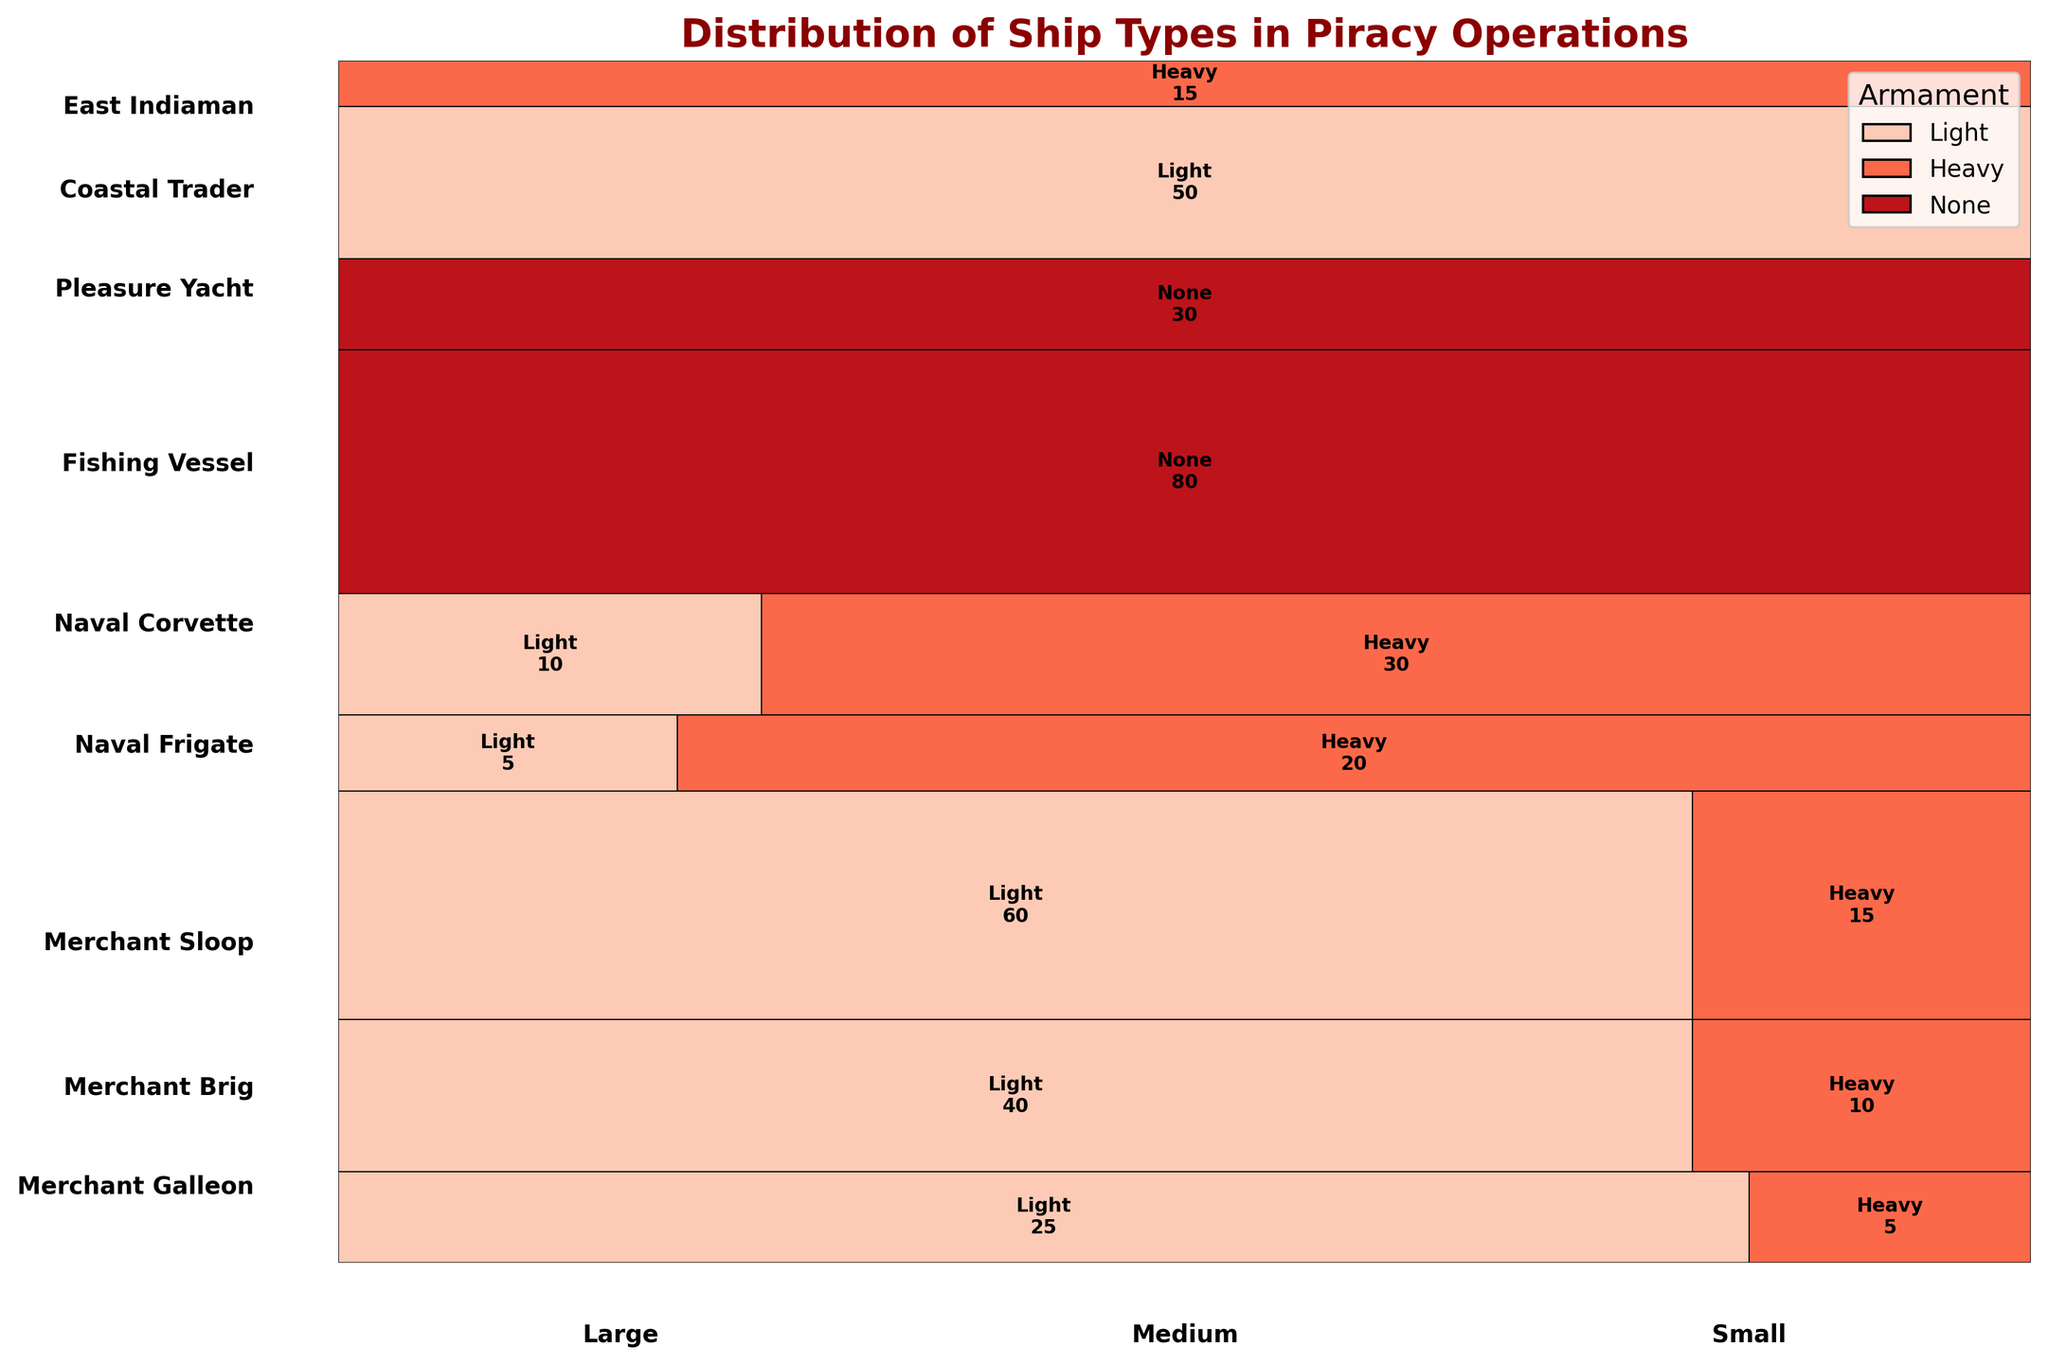What's the title of the plot? The title can be found at the top of the figure.
Answer: Distribution of Ship Types in Piracy Operations How is the figure color-coded? Each armament type is represented by a different color, as shown in the legend in the upper right corner.
Answer: Different colors for different armaments Which ship type has the highest frequency? The size of each section in the vertical axis indicates its frequency. The largest section corresponds to the 'Fishing Vessel.'
Answer: Fishing Vessel How many large merchant galleons with heavy armament were encountered? Look for the section labeled 'Merchant Galleon' and identify the portion corresponding to large size and heavy armament.
Answer: 5 How does the total frequency of merchant ships compare to naval ships? Calculate the combined frequency for all merchant ship types and compare it to the combined frequency for all naval ship types. Adding up frequencies: Merchant (25+5+40+10+60+15)=155 and Naval (5+20+10+30)=65.
Answer: Merchant ships' total frequency is higher Is the number of light-armed coastal traders higher than light-armed naval corvettes? Compare the sections for coastal traders (labeled as 'Small' and 'Light') to the naval corvettes (labeled 'Medium' and 'Light').
Answer: Yes What is the proportion of lightly armed to heavily armed naval frigates? Find the sections for Naval Frigate ('Large') with light and heavy armament and compare their sizes. The count for light is 5, and for heavy is 20.
Answer: 1:4 Which ship size has the highest frequency of occurrences with no armament? Refer to the sections labeled 'None' and compare them across different sizes.
Answer: Small Among the ships with heavy armament, which type is the least encountered? Look for the sections labeled 'Heavy' and identify the smallest portion among the ship types classified as having heavily armed.
Answer: Merchant Galleon What is the most common armament type for encountered small-sized ships? Summarize the counts for 'Light,' 'Heavy,' and 'None' for 'Small' size ships. The 'None' category is most prevalent.
Answer: None 